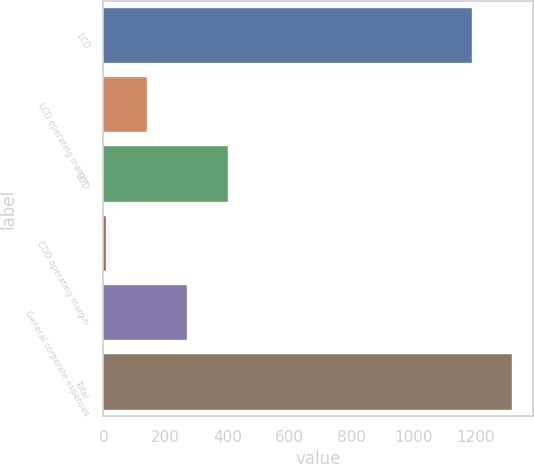Convert chart to OTSL. <chart><loc_0><loc_0><loc_500><loc_500><bar_chart><fcel>LCD<fcel>LCD operating margin<fcel>CDD<fcel>CDD operating margin<fcel>General corporate expenses<fcel>Total<nl><fcel>1187.6<fcel>139.88<fcel>400.44<fcel>9.6<fcel>270.16<fcel>1317.88<nl></chart> 